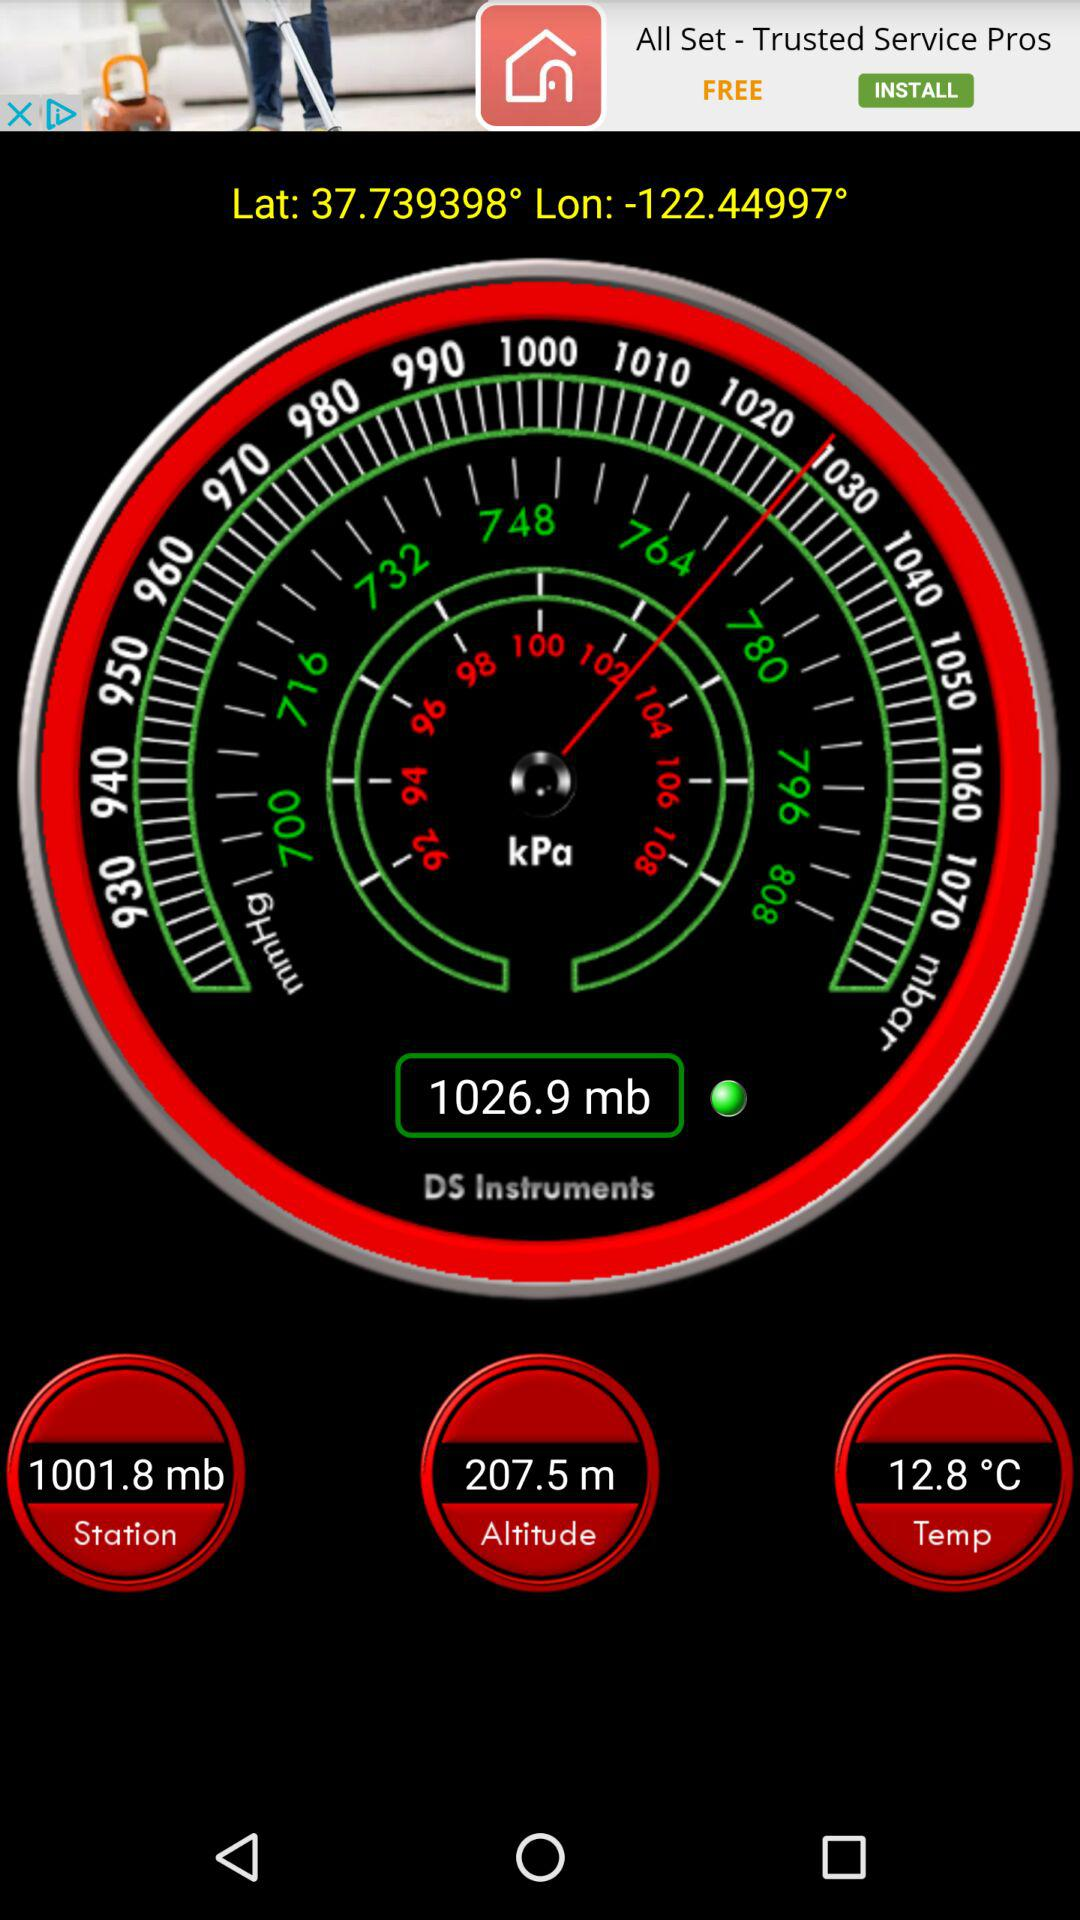What is the shown temperature? The shown temperature is 12.8 °C. 